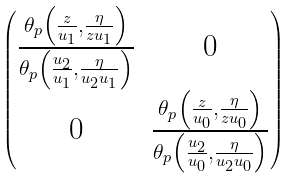<formula> <loc_0><loc_0><loc_500><loc_500>\begin{pmatrix} \frac { \theta _ { p } \left ( \frac { z } { u _ { 1 } } , \frac { \eta } { z u _ { 1 } } \right ) } { \theta _ { p } \left ( \frac { u _ { 2 } } { u _ { 1 } } , \frac { \eta } { u _ { 2 } u _ { 1 } } \right ) } & 0 \\ 0 & \frac { \theta _ { p } \left ( \frac { z } { u _ { 0 } } , \frac { \eta } { z u _ { 0 } } \right ) } { \theta _ { p } \left ( \frac { u _ { 2 } } { u _ { 0 } } , \frac { \eta } { u _ { 2 } u _ { 0 } } \right ) } \end{pmatrix}</formula> 